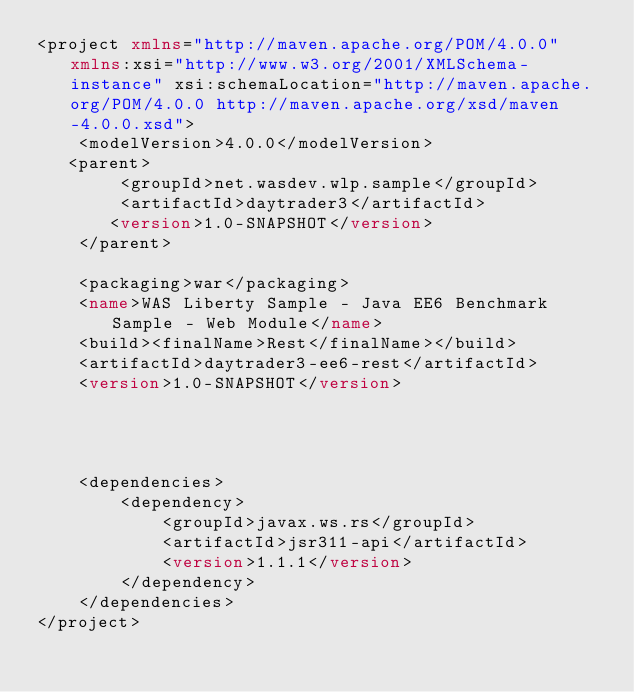<code> <loc_0><loc_0><loc_500><loc_500><_XML_><project xmlns="http://maven.apache.org/POM/4.0.0" xmlns:xsi="http://www.w3.org/2001/XMLSchema-instance" xsi:schemaLocation="http://maven.apache.org/POM/4.0.0 http://maven.apache.org/xsd/maven-4.0.0.xsd">
    <modelVersion>4.0.0</modelVersion>
   <parent>
        <groupId>net.wasdev.wlp.sample</groupId>
        <artifactId>daytrader3</artifactId>
       <version>1.0-SNAPSHOT</version>
    </parent>

    <packaging>war</packaging>
    <name>WAS Liberty Sample - Java EE6 Benchmark Sample - Web Module</name>
	<build><finalName>Rest</finalName></build>
	<artifactId>daytrader3-ee6-rest</artifactId>
	<version>1.0-SNAPSHOT</version>




	<dependencies>
		<dependency>
			<groupId>javax.ws.rs</groupId>
			<artifactId>jsr311-api</artifactId>
			<version>1.1.1</version>
		</dependency>
	</dependencies>
</project>
</code> 